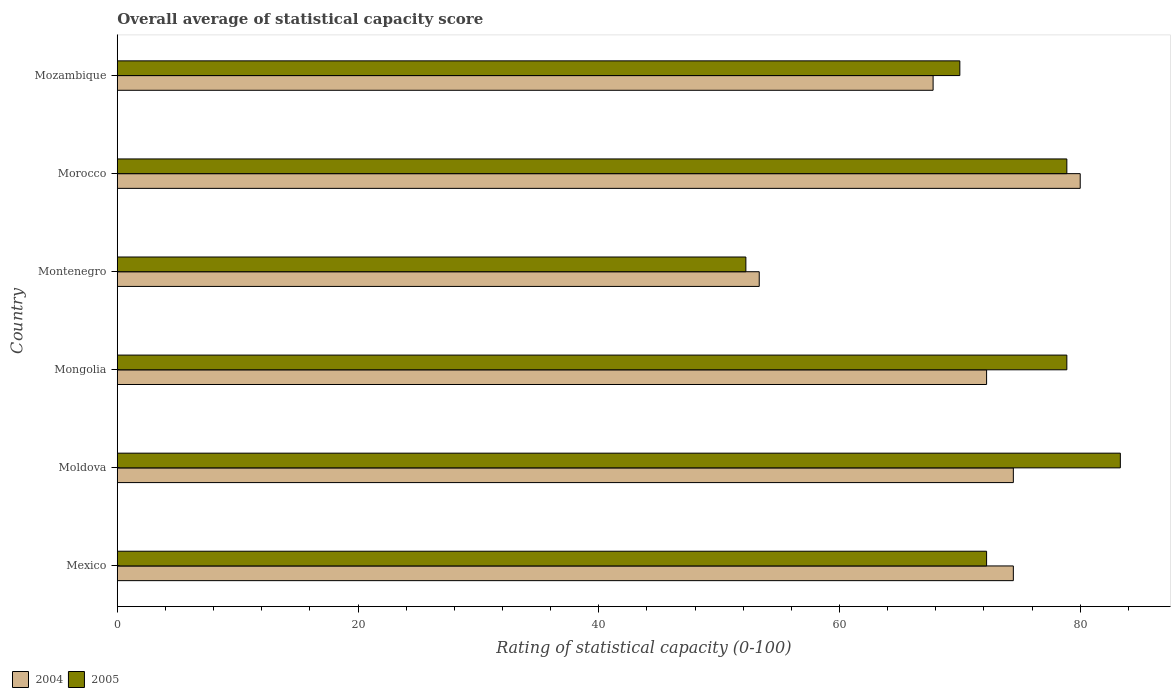How many different coloured bars are there?
Make the answer very short. 2. Are the number of bars on each tick of the Y-axis equal?
Your answer should be very brief. Yes. How many bars are there on the 6th tick from the bottom?
Provide a succinct answer. 2. What is the label of the 2nd group of bars from the top?
Keep it short and to the point. Morocco. In how many cases, is the number of bars for a given country not equal to the number of legend labels?
Make the answer very short. 0. What is the rating of statistical capacity in 2005 in Morocco?
Offer a terse response. 78.89. Across all countries, what is the maximum rating of statistical capacity in 2005?
Provide a succinct answer. 83.33. Across all countries, what is the minimum rating of statistical capacity in 2004?
Offer a terse response. 53.33. In which country was the rating of statistical capacity in 2005 maximum?
Offer a very short reply. Moldova. In which country was the rating of statistical capacity in 2004 minimum?
Make the answer very short. Montenegro. What is the total rating of statistical capacity in 2004 in the graph?
Provide a succinct answer. 422.22. What is the difference between the rating of statistical capacity in 2005 in Mexico and that in Moldova?
Keep it short and to the point. -11.11. What is the difference between the rating of statistical capacity in 2005 in Mexico and the rating of statistical capacity in 2004 in Moldova?
Provide a succinct answer. -2.22. What is the average rating of statistical capacity in 2004 per country?
Your response must be concise. 70.37. What is the difference between the rating of statistical capacity in 2004 and rating of statistical capacity in 2005 in Moldova?
Ensure brevity in your answer.  -8.89. What is the ratio of the rating of statistical capacity in 2004 in Moldova to that in Montenegro?
Make the answer very short. 1.4. Is the rating of statistical capacity in 2005 in Mexico less than that in Morocco?
Your response must be concise. Yes. Is the difference between the rating of statistical capacity in 2004 in Moldova and Mongolia greater than the difference between the rating of statistical capacity in 2005 in Moldova and Mongolia?
Your answer should be very brief. No. What is the difference between the highest and the second highest rating of statistical capacity in 2005?
Ensure brevity in your answer.  4.44. What is the difference between the highest and the lowest rating of statistical capacity in 2005?
Your answer should be very brief. 31.11. What does the 1st bar from the top in Moldova represents?
Offer a very short reply. 2005. What does the 1st bar from the bottom in Mexico represents?
Provide a succinct answer. 2004. How many countries are there in the graph?
Provide a succinct answer. 6. What is the difference between two consecutive major ticks on the X-axis?
Your answer should be compact. 20. Does the graph contain grids?
Your answer should be compact. No. Where does the legend appear in the graph?
Provide a short and direct response. Bottom left. How are the legend labels stacked?
Keep it short and to the point. Horizontal. What is the title of the graph?
Your answer should be very brief. Overall average of statistical capacity score. Does "1974" appear as one of the legend labels in the graph?
Your answer should be compact. No. What is the label or title of the X-axis?
Your response must be concise. Rating of statistical capacity (0-100). What is the Rating of statistical capacity (0-100) in 2004 in Mexico?
Offer a very short reply. 74.44. What is the Rating of statistical capacity (0-100) in 2005 in Mexico?
Ensure brevity in your answer.  72.22. What is the Rating of statistical capacity (0-100) of 2004 in Moldova?
Give a very brief answer. 74.44. What is the Rating of statistical capacity (0-100) of 2005 in Moldova?
Give a very brief answer. 83.33. What is the Rating of statistical capacity (0-100) in 2004 in Mongolia?
Provide a short and direct response. 72.22. What is the Rating of statistical capacity (0-100) of 2005 in Mongolia?
Make the answer very short. 78.89. What is the Rating of statistical capacity (0-100) in 2004 in Montenegro?
Give a very brief answer. 53.33. What is the Rating of statistical capacity (0-100) in 2005 in Montenegro?
Provide a succinct answer. 52.22. What is the Rating of statistical capacity (0-100) of 2005 in Morocco?
Provide a short and direct response. 78.89. What is the Rating of statistical capacity (0-100) in 2004 in Mozambique?
Keep it short and to the point. 67.78. What is the Rating of statistical capacity (0-100) in 2005 in Mozambique?
Offer a very short reply. 70. Across all countries, what is the maximum Rating of statistical capacity (0-100) of 2004?
Your answer should be compact. 80. Across all countries, what is the maximum Rating of statistical capacity (0-100) of 2005?
Your answer should be compact. 83.33. Across all countries, what is the minimum Rating of statistical capacity (0-100) of 2004?
Offer a terse response. 53.33. Across all countries, what is the minimum Rating of statistical capacity (0-100) in 2005?
Offer a very short reply. 52.22. What is the total Rating of statistical capacity (0-100) in 2004 in the graph?
Provide a succinct answer. 422.22. What is the total Rating of statistical capacity (0-100) in 2005 in the graph?
Offer a terse response. 435.56. What is the difference between the Rating of statistical capacity (0-100) in 2004 in Mexico and that in Moldova?
Offer a terse response. 0. What is the difference between the Rating of statistical capacity (0-100) in 2005 in Mexico and that in Moldova?
Provide a short and direct response. -11.11. What is the difference between the Rating of statistical capacity (0-100) in 2004 in Mexico and that in Mongolia?
Make the answer very short. 2.22. What is the difference between the Rating of statistical capacity (0-100) in 2005 in Mexico and that in Mongolia?
Provide a short and direct response. -6.67. What is the difference between the Rating of statistical capacity (0-100) in 2004 in Mexico and that in Montenegro?
Provide a short and direct response. 21.11. What is the difference between the Rating of statistical capacity (0-100) of 2005 in Mexico and that in Montenegro?
Offer a terse response. 20. What is the difference between the Rating of statistical capacity (0-100) in 2004 in Mexico and that in Morocco?
Provide a short and direct response. -5.56. What is the difference between the Rating of statistical capacity (0-100) in 2005 in Mexico and that in Morocco?
Your response must be concise. -6.67. What is the difference between the Rating of statistical capacity (0-100) in 2005 in Mexico and that in Mozambique?
Keep it short and to the point. 2.22. What is the difference between the Rating of statistical capacity (0-100) of 2004 in Moldova and that in Mongolia?
Offer a very short reply. 2.22. What is the difference between the Rating of statistical capacity (0-100) in 2005 in Moldova and that in Mongolia?
Provide a short and direct response. 4.44. What is the difference between the Rating of statistical capacity (0-100) of 2004 in Moldova and that in Montenegro?
Your answer should be very brief. 21.11. What is the difference between the Rating of statistical capacity (0-100) of 2005 in Moldova and that in Montenegro?
Your answer should be very brief. 31.11. What is the difference between the Rating of statistical capacity (0-100) in 2004 in Moldova and that in Morocco?
Offer a terse response. -5.56. What is the difference between the Rating of statistical capacity (0-100) in 2005 in Moldova and that in Morocco?
Keep it short and to the point. 4.44. What is the difference between the Rating of statistical capacity (0-100) of 2005 in Moldova and that in Mozambique?
Your answer should be compact. 13.33. What is the difference between the Rating of statistical capacity (0-100) in 2004 in Mongolia and that in Montenegro?
Keep it short and to the point. 18.89. What is the difference between the Rating of statistical capacity (0-100) of 2005 in Mongolia and that in Montenegro?
Keep it short and to the point. 26.67. What is the difference between the Rating of statistical capacity (0-100) in 2004 in Mongolia and that in Morocco?
Give a very brief answer. -7.78. What is the difference between the Rating of statistical capacity (0-100) in 2005 in Mongolia and that in Morocco?
Your answer should be very brief. 0. What is the difference between the Rating of statistical capacity (0-100) of 2004 in Mongolia and that in Mozambique?
Ensure brevity in your answer.  4.44. What is the difference between the Rating of statistical capacity (0-100) in 2005 in Mongolia and that in Mozambique?
Offer a terse response. 8.89. What is the difference between the Rating of statistical capacity (0-100) of 2004 in Montenegro and that in Morocco?
Your answer should be very brief. -26.67. What is the difference between the Rating of statistical capacity (0-100) of 2005 in Montenegro and that in Morocco?
Make the answer very short. -26.67. What is the difference between the Rating of statistical capacity (0-100) in 2004 in Montenegro and that in Mozambique?
Offer a terse response. -14.44. What is the difference between the Rating of statistical capacity (0-100) of 2005 in Montenegro and that in Mozambique?
Offer a terse response. -17.78. What is the difference between the Rating of statistical capacity (0-100) in 2004 in Morocco and that in Mozambique?
Make the answer very short. 12.22. What is the difference between the Rating of statistical capacity (0-100) in 2005 in Morocco and that in Mozambique?
Provide a short and direct response. 8.89. What is the difference between the Rating of statistical capacity (0-100) in 2004 in Mexico and the Rating of statistical capacity (0-100) in 2005 in Moldova?
Give a very brief answer. -8.89. What is the difference between the Rating of statistical capacity (0-100) in 2004 in Mexico and the Rating of statistical capacity (0-100) in 2005 in Mongolia?
Keep it short and to the point. -4.44. What is the difference between the Rating of statistical capacity (0-100) in 2004 in Mexico and the Rating of statistical capacity (0-100) in 2005 in Montenegro?
Offer a terse response. 22.22. What is the difference between the Rating of statistical capacity (0-100) in 2004 in Mexico and the Rating of statistical capacity (0-100) in 2005 in Morocco?
Ensure brevity in your answer.  -4.44. What is the difference between the Rating of statistical capacity (0-100) of 2004 in Mexico and the Rating of statistical capacity (0-100) of 2005 in Mozambique?
Your answer should be very brief. 4.44. What is the difference between the Rating of statistical capacity (0-100) in 2004 in Moldova and the Rating of statistical capacity (0-100) in 2005 in Mongolia?
Your response must be concise. -4.44. What is the difference between the Rating of statistical capacity (0-100) of 2004 in Moldova and the Rating of statistical capacity (0-100) of 2005 in Montenegro?
Offer a terse response. 22.22. What is the difference between the Rating of statistical capacity (0-100) in 2004 in Moldova and the Rating of statistical capacity (0-100) in 2005 in Morocco?
Keep it short and to the point. -4.44. What is the difference between the Rating of statistical capacity (0-100) of 2004 in Moldova and the Rating of statistical capacity (0-100) of 2005 in Mozambique?
Ensure brevity in your answer.  4.44. What is the difference between the Rating of statistical capacity (0-100) of 2004 in Mongolia and the Rating of statistical capacity (0-100) of 2005 in Montenegro?
Offer a terse response. 20. What is the difference between the Rating of statistical capacity (0-100) in 2004 in Mongolia and the Rating of statistical capacity (0-100) in 2005 in Morocco?
Offer a terse response. -6.67. What is the difference between the Rating of statistical capacity (0-100) of 2004 in Mongolia and the Rating of statistical capacity (0-100) of 2005 in Mozambique?
Your response must be concise. 2.22. What is the difference between the Rating of statistical capacity (0-100) in 2004 in Montenegro and the Rating of statistical capacity (0-100) in 2005 in Morocco?
Your answer should be compact. -25.56. What is the difference between the Rating of statistical capacity (0-100) of 2004 in Montenegro and the Rating of statistical capacity (0-100) of 2005 in Mozambique?
Provide a short and direct response. -16.67. What is the difference between the Rating of statistical capacity (0-100) of 2004 in Morocco and the Rating of statistical capacity (0-100) of 2005 in Mozambique?
Keep it short and to the point. 10. What is the average Rating of statistical capacity (0-100) in 2004 per country?
Offer a very short reply. 70.37. What is the average Rating of statistical capacity (0-100) of 2005 per country?
Provide a succinct answer. 72.59. What is the difference between the Rating of statistical capacity (0-100) of 2004 and Rating of statistical capacity (0-100) of 2005 in Mexico?
Offer a very short reply. 2.22. What is the difference between the Rating of statistical capacity (0-100) of 2004 and Rating of statistical capacity (0-100) of 2005 in Moldova?
Your answer should be compact. -8.89. What is the difference between the Rating of statistical capacity (0-100) of 2004 and Rating of statistical capacity (0-100) of 2005 in Mongolia?
Provide a short and direct response. -6.67. What is the difference between the Rating of statistical capacity (0-100) of 2004 and Rating of statistical capacity (0-100) of 2005 in Montenegro?
Provide a succinct answer. 1.11. What is the difference between the Rating of statistical capacity (0-100) of 2004 and Rating of statistical capacity (0-100) of 2005 in Morocco?
Make the answer very short. 1.11. What is the difference between the Rating of statistical capacity (0-100) in 2004 and Rating of statistical capacity (0-100) in 2005 in Mozambique?
Ensure brevity in your answer.  -2.22. What is the ratio of the Rating of statistical capacity (0-100) of 2004 in Mexico to that in Moldova?
Offer a terse response. 1. What is the ratio of the Rating of statistical capacity (0-100) of 2005 in Mexico to that in Moldova?
Offer a very short reply. 0.87. What is the ratio of the Rating of statistical capacity (0-100) of 2004 in Mexico to that in Mongolia?
Keep it short and to the point. 1.03. What is the ratio of the Rating of statistical capacity (0-100) in 2005 in Mexico to that in Mongolia?
Keep it short and to the point. 0.92. What is the ratio of the Rating of statistical capacity (0-100) in 2004 in Mexico to that in Montenegro?
Provide a short and direct response. 1.4. What is the ratio of the Rating of statistical capacity (0-100) of 2005 in Mexico to that in Montenegro?
Make the answer very short. 1.38. What is the ratio of the Rating of statistical capacity (0-100) in 2004 in Mexico to that in Morocco?
Your response must be concise. 0.93. What is the ratio of the Rating of statistical capacity (0-100) of 2005 in Mexico to that in Morocco?
Give a very brief answer. 0.92. What is the ratio of the Rating of statistical capacity (0-100) in 2004 in Mexico to that in Mozambique?
Your response must be concise. 1.1. What is the ratio of the Rating of statistical capacity (0-100) of 2005 in Mexico to that in Mozambique?
Your answer should be compact. 1.03. What is the ratio of the Rating of statistical capacity (0-100) of 2004 in Moldova to that in Mongolia?
Ensure brevity in your answer.  1.03. What is the ratio of the Rating of statistical capacity (0-100) of 2005 in Moldova to that in Mongolia?
Offer a very short reply. 1.06. What is the ratio of the Rating of statistical capacity (0-100) of 2004 in Moldova to that in Montenegro?
Provide a succinct answer. 1.4. What is the ratio of the Rating of statistical capacity (0-100) in 2005 in Moldova to that in Montenegro?
Your response must be concise. 1.6. What is the ratio of the Rating of statistical capacity (0-100) of 2004 in Moldova to that in Morocco?
Keep it short and to the point. 0.93. What is the ratio of the Rating of statistical capacity (0-100) of 2005 in Moldova to that in Morocco?
Provide a succinct answer. 1.06. What is the ratio of the Rating of statistical capacity (0-100) in 2004 in Moldova to that in Mozambique?
Ensure brevity in your answer.  1.1. What is the ratio of the Rating of statistical capacity (0-100) in 2005 in Moldova to that in Mozambique?
Ensure brevity in your answer.  1.19. What is the ratio of the Rating of statistical capacity (0-100) in 2004 in Mongolia to that in Montenegro?
Ensure brevity in your answer.  1.35. What is the ratio of the Rating of statistical capacity (0-100) of 2005 in Mongolia to that in Montenegro?
Keep it short and to the point. 1.51. What is the ratio of the Rating of statistical capacity (0-100) in 2004 in Mongolia to that in Morocco?
Your answer should be compact. 0.9. What is the ratio of the Rating of statistical capacity (0-100) in 2004 in Mongolia to that in Mozambique?
Ensure brevity in your answer.  1.07. What is the ratio of the Rating of statistical capacity (0-100) of 2005 in Mongolia to that in Mozambique?
Provide a succinct answer. 1.13. What is the ratio of the Rating of statistical capacity (0-100) in 2005 in Montenegro to that in Morocco?
Make the answer very short. 0.66. What is the ratio of the Rating of statistical capacity (0-100) in 2004 in Montenegro to that in Mozambique?
Your answer should be very brief. 0.79. What is the ratio of the Rating of statistical capacity (0-100) of 2005 in Montenegro to that in Mozambique?
Offer a terse response. 0.75. What is the ratio of the Rating of statistical capacity (0-100) of 2004 in Morocco to that in Mozambique?
Offer a terse response. 1.18. What is the ratio of the Rating of statistical capacity (0-100) of 2005 in Morocco to that in Mozambique?
Ensure brevity in your answer.  1.13. What is the difference between the highest and the second highest Rating of statistical capacity (0-100) of 2004?
Offer a terse response. 5.56. What is the difference between the highest and the second highest Rating of statistical capacity (0-100) in 2005?
Make the answer very short. 4.44. What is the difference between the highest and the lowest Rating of statistical capacity (0-100) of 2004?
Ensure brevity in your answer.  26.67. What is the difference between the highest and the lowest Rating of statistical capacity (0-100) in 2005?
Your answer should be compact. 31.11. 